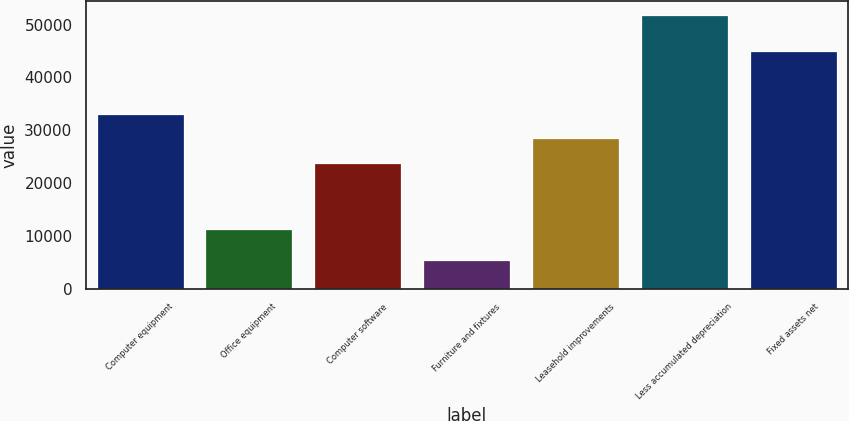Convert chart. <chart><loc_0><loc_0><loc_500><loc_500><bar_chart><fcel>Computer equipment<fcel>Office equipment<fcel>Computer software<fcel>Furniture and fixtures<fcel>Leasehold improvements<fcel>Less accumulated depreciation<fcel>Fixed assets net<nl><fcel>33094<fcel>11315<fcel>23832<fcel>5535<fcel>28463<fcel>51845<fcel>44986<nl></chart> 